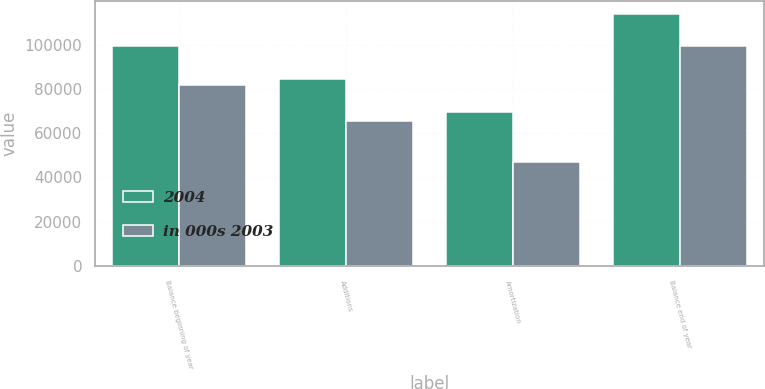Convert chart. <chart><loc_0><loc_0><loc_500><loc_500><stacked_bar_chart><ecel><fcel>Balance beginning of year<fcel>Additions<fcel>Amortization<fcel>Balance end of year<nl><fcel>2004<fcel>99265<fcel>84274<fcel>69718<fcel>113821<nl><fcel>in 000s 2003<fcel>81893<fcel>65345<fcel>47107<fcel>99265<nl></chart> 